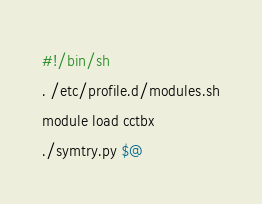Convert code to text. <code><loc_0><loc_0><loc_500><loc_500><_Bash_>#!/bin/sh
. /etc/profile.d/modules.sh
module load cctbx
./symtry.py $@</code> 